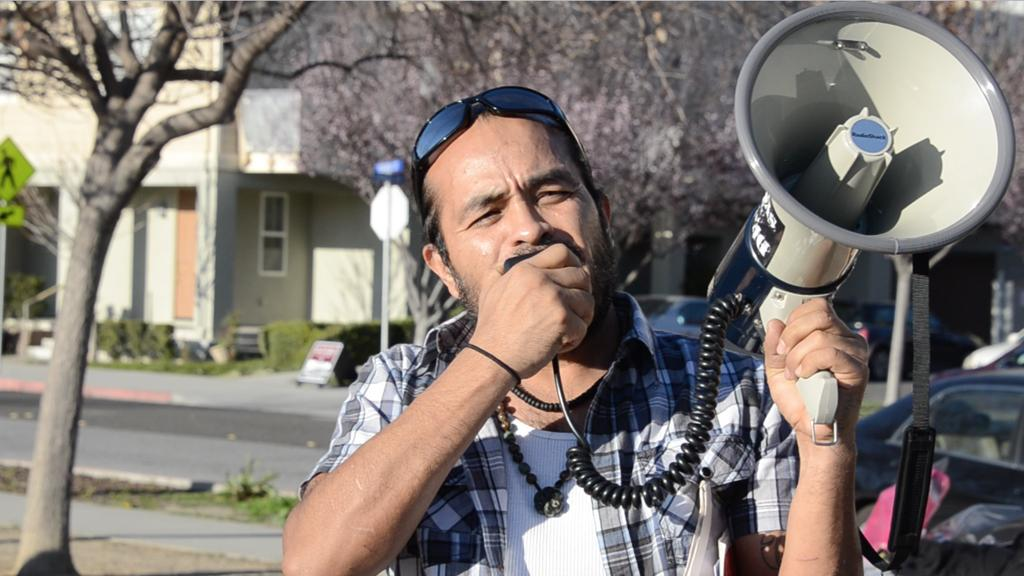Who is in the image? There is a man in the image. What is the man holding in his hands? The man is holding a megaphone in his hands. What is the man doing with the megaphone? The man is speaking. What can be seen in the background of the image? There is a building and trees in the background of the image. What type of destruction can be seen happening to the building in the image? There is no destruction visible in the image; the building appears intact. How many trains are visible in the image? There are no trains present in the image. 